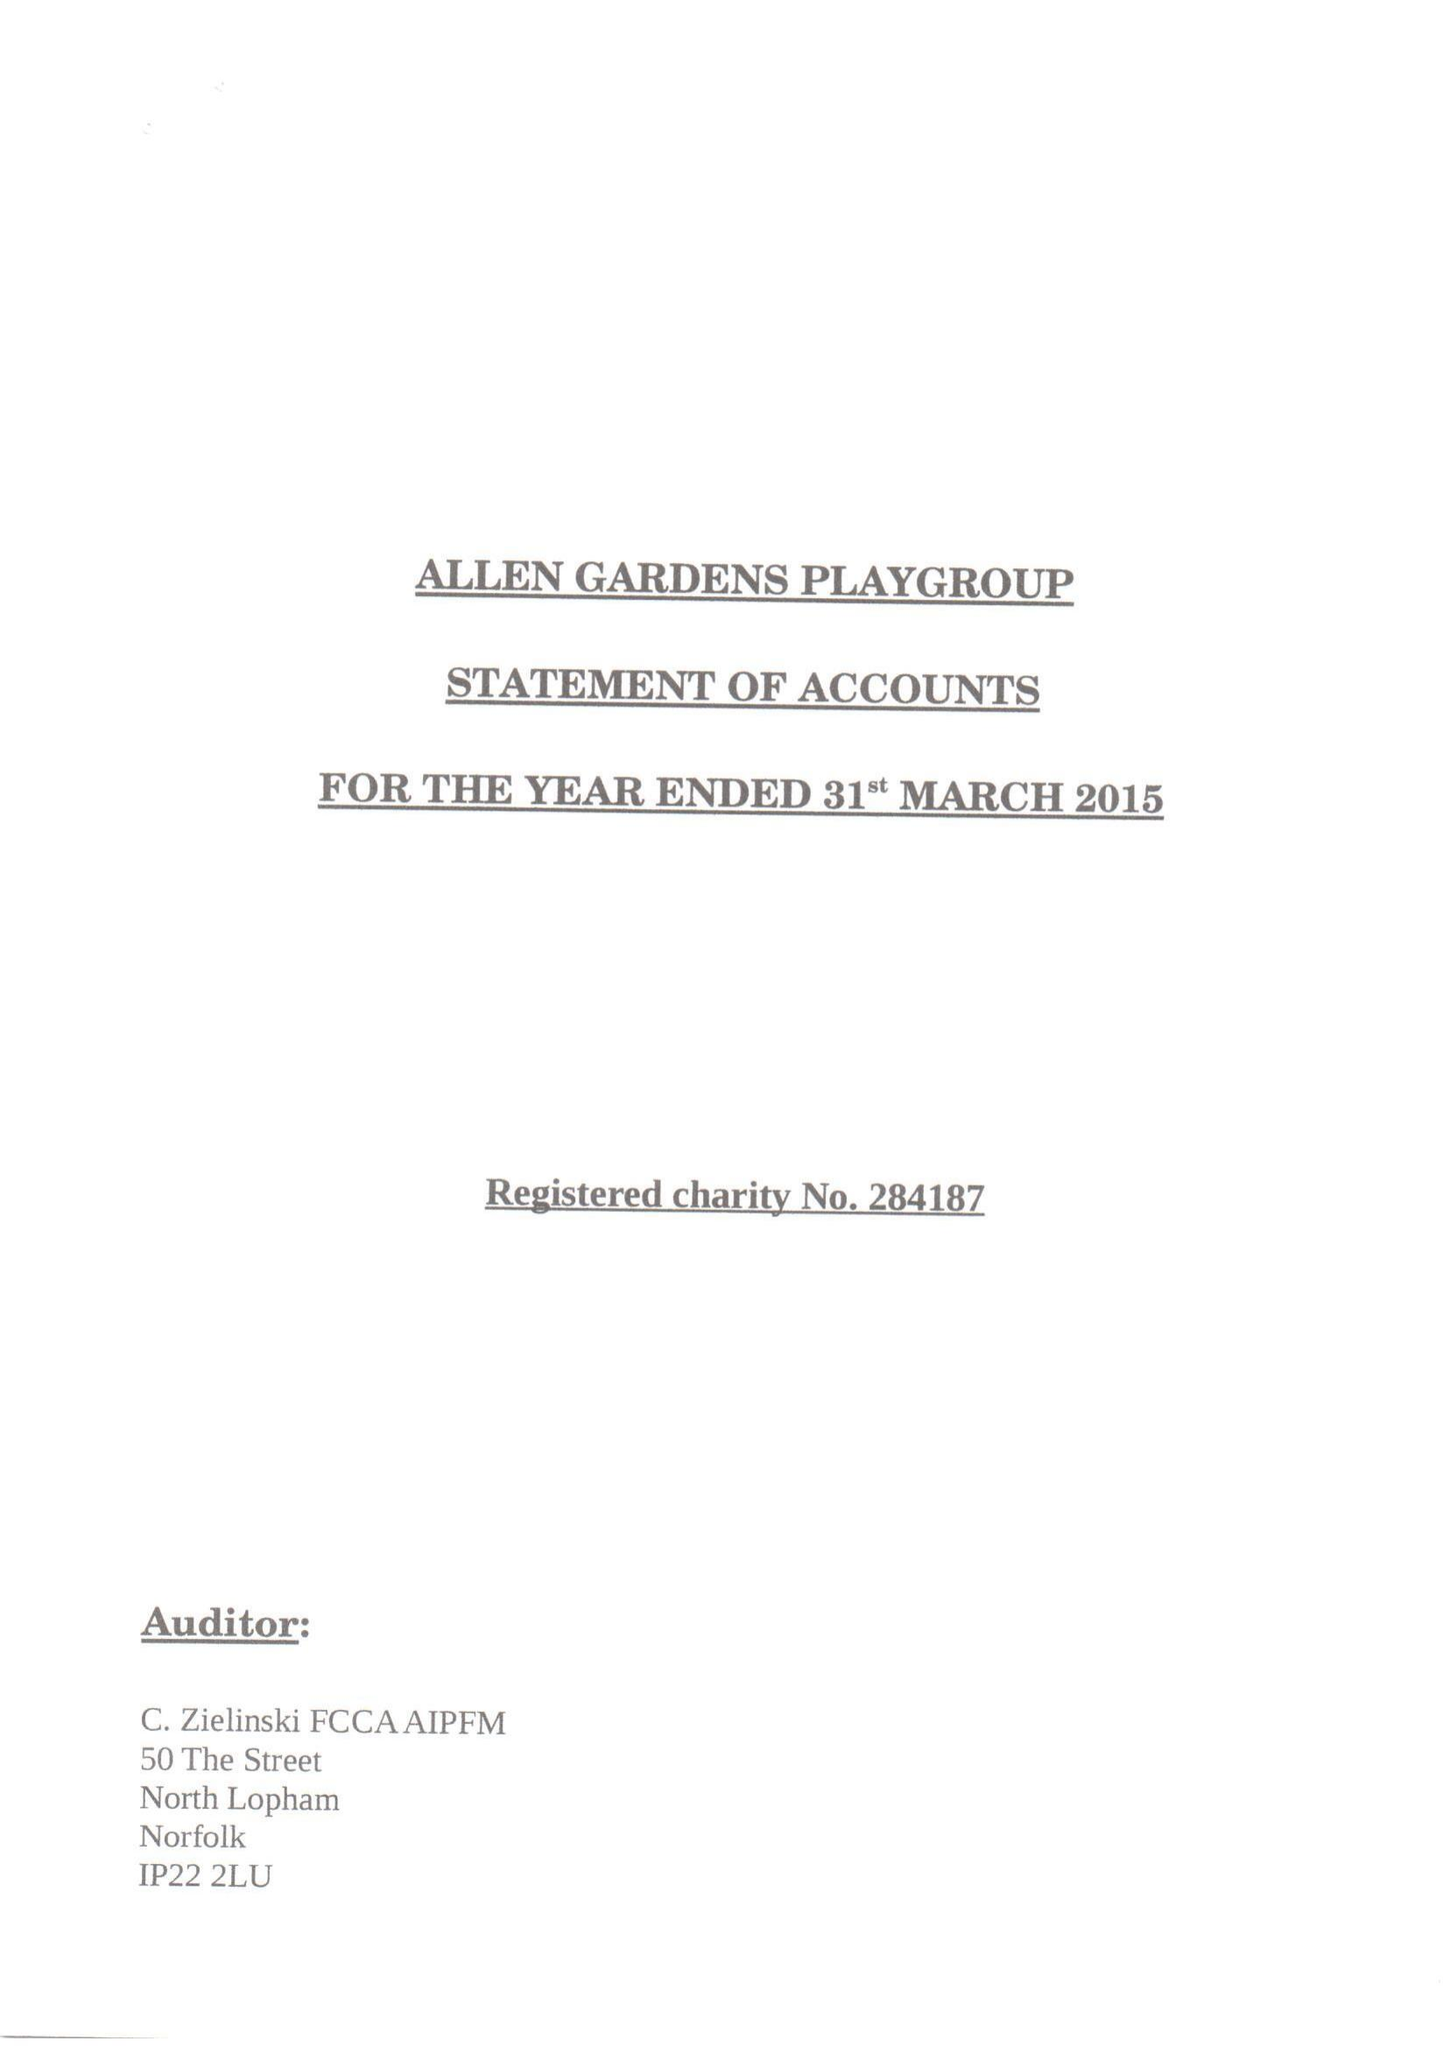What is the value for the income_annually_in_british_pounds?
Answer the question using a single word or phrase. 83474.00 